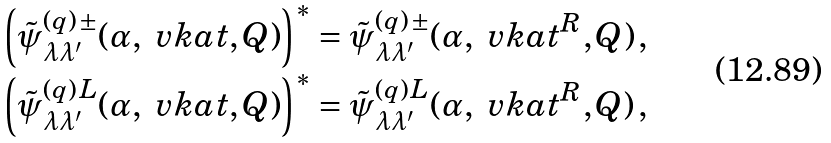Convert formula to latex. <formula><loc_0><loc_0><loc_500><loc_500>\left ( \tilde { \psi } ^ { ( q ) \, \pm } _ { \lambda \lambda ^ { \prime } } ( \alpha , \ v k a t , Q ) \right ) ^ { * } & = \tilde { \psi } ^ { ( q ) \, \pm } _ { \lambda \lambda ^ { \prime } } ( \alpha , \ v k a t ^ { R } , Q ) \, , \\ \left ( \tilde { \psi } ^ { ( q ) \, L } _ { \lambda \lambda ^ { \prime } } ( \alpha , \ v k a t , Q ) \right ) ^ { * } & = \tilde { \psi } ^ { ( q ) \, L } _ { \lambda \lambda ^ { \prime } } ( \alpha , \ v k a t ^ { R } , Q ) \, ,</formula> 